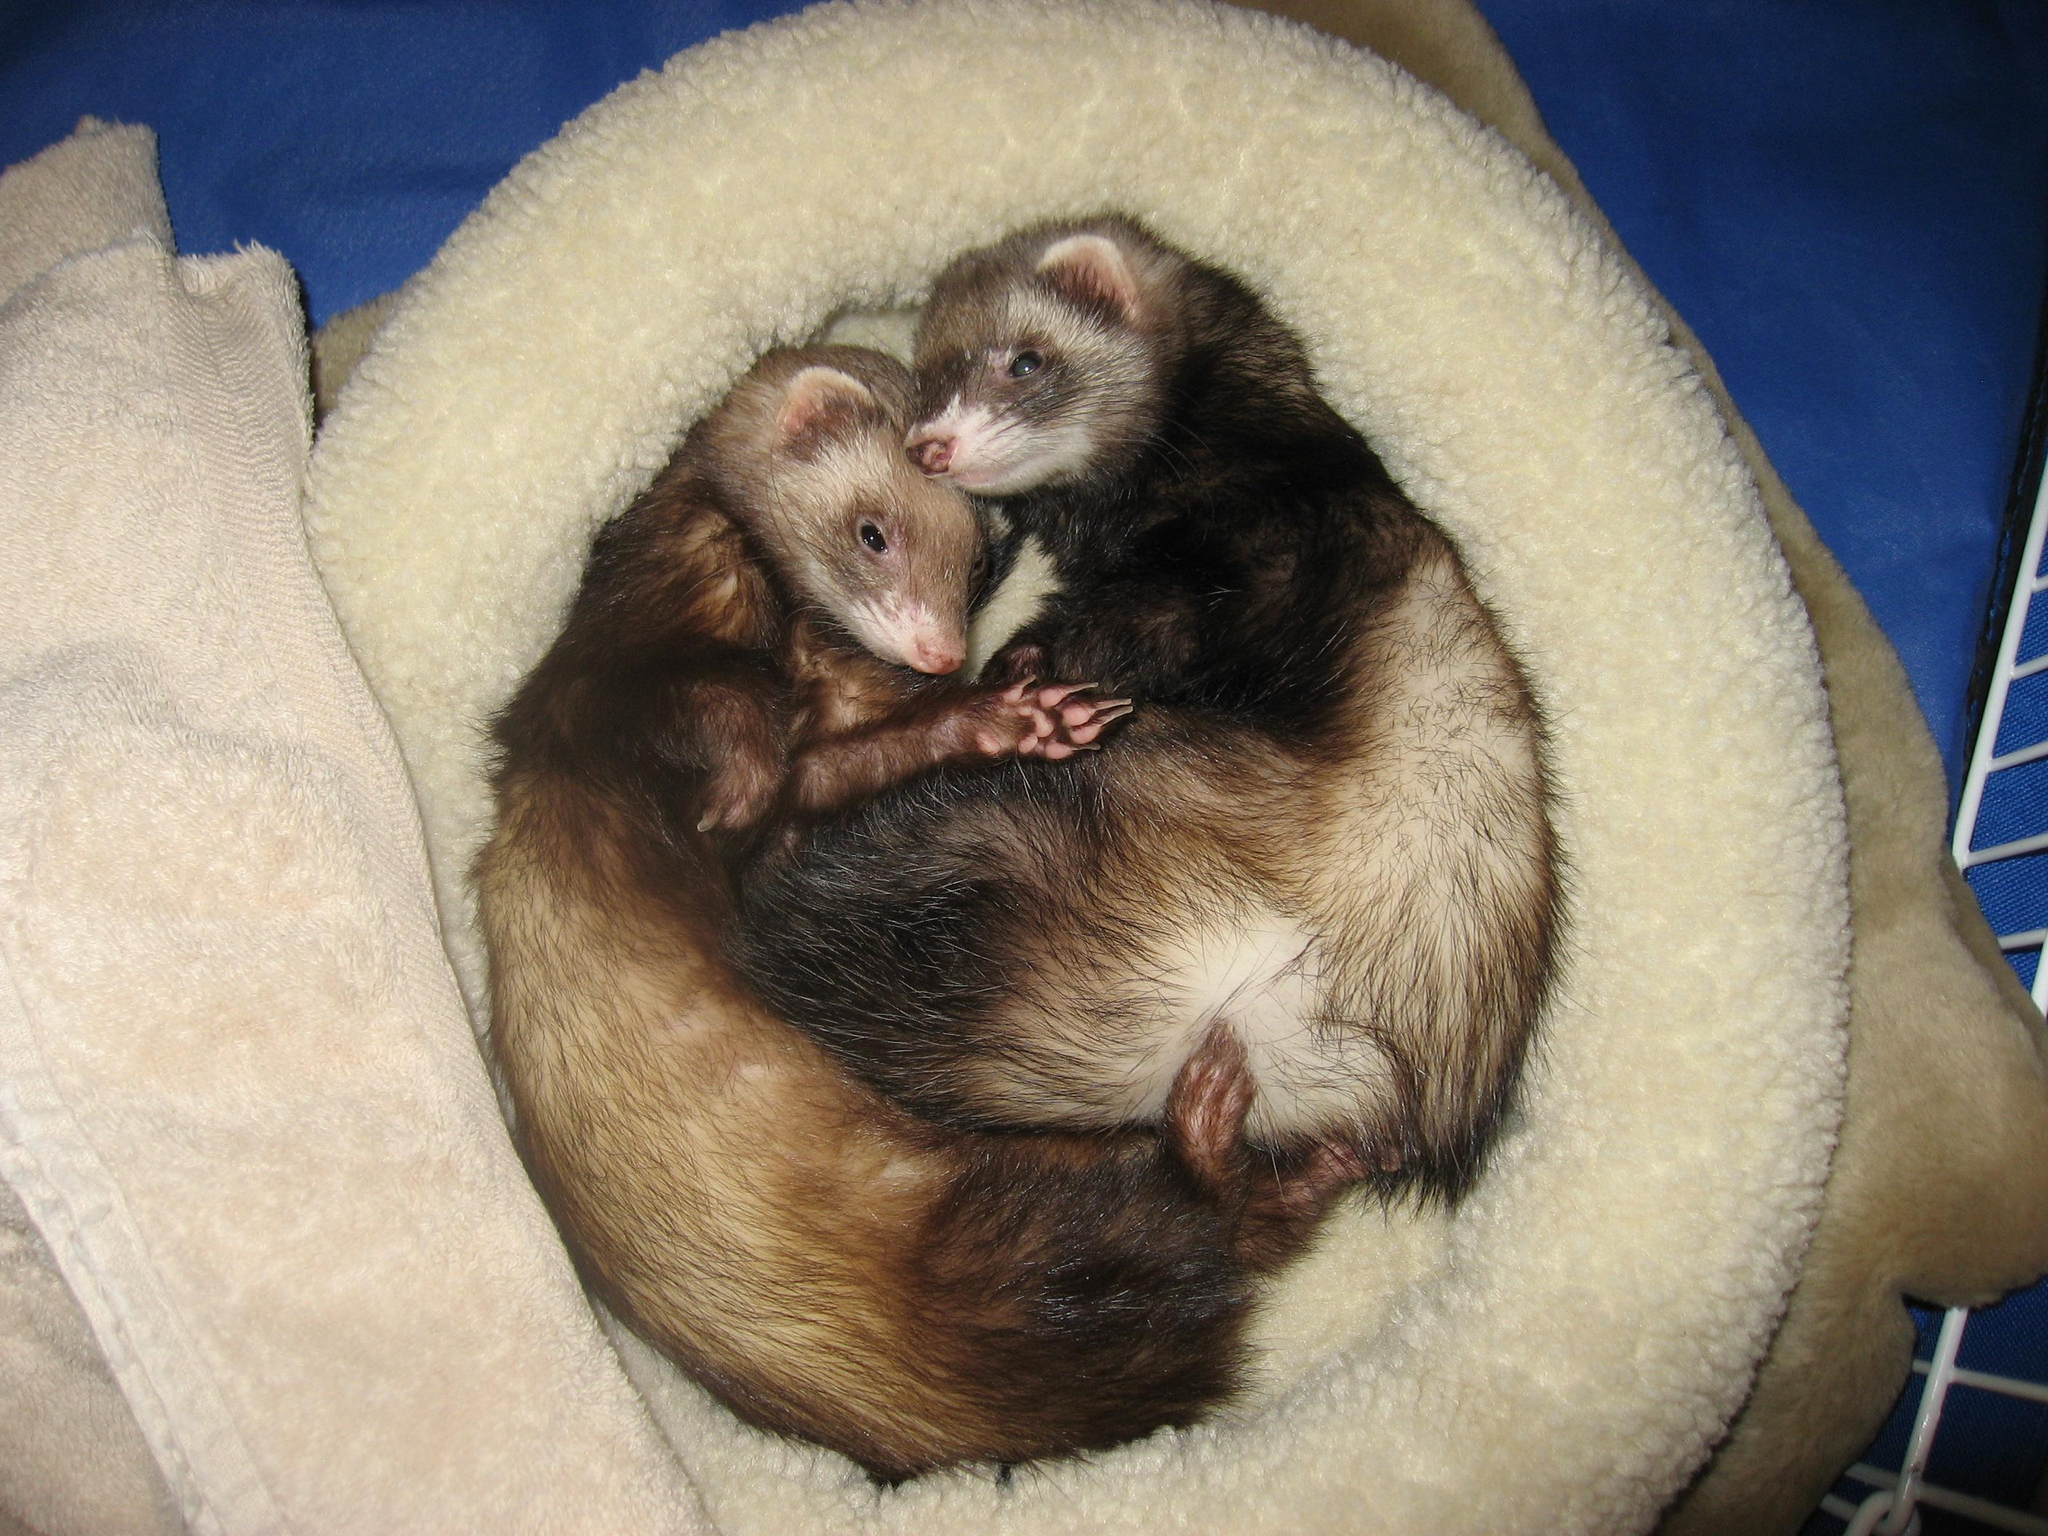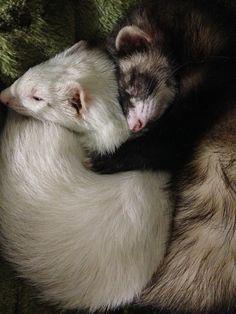The first image is the image on the left, the second image is the image on the right. Analyze the images presented: Is the assertion "An image shows two ferrets snuggling to form a ball shape face-to-face." valid? Answer yes or no. Yes. 